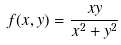<formula> <loc_0><loc_0><loc_500><loc_500>f ( x , y ) = \frac { x y } { x ^ { 2 } + y ^ { 2 } }</formula> 